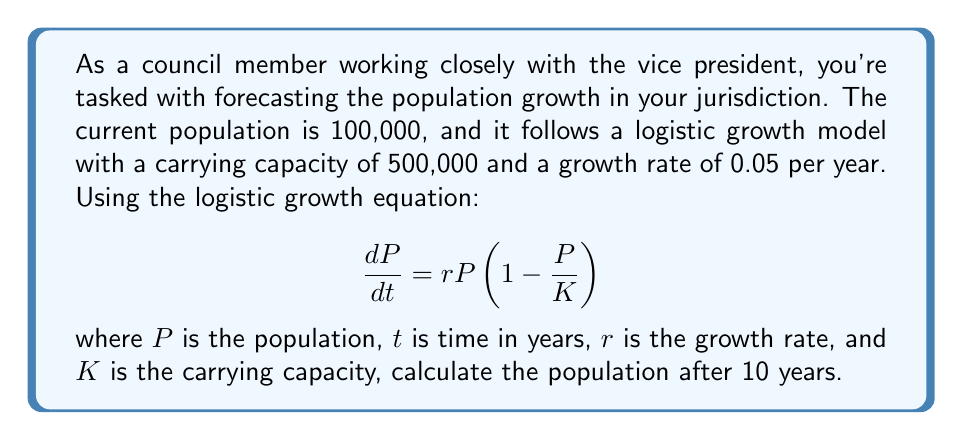Help me with this question. To solve this problem, we'll use the logistic growth model solution:

$$P(t) = \frac{K}{1 + (\frac{K}{P_0} - 1)e^{-rt}}$$

Where:
$K = 500,000$ (carrying capacity)
$P_0 = 100,000$ (initial population)
$r = 0.05$ (growth rate)
$t = 10$ (time in years)

Let's substitute these values into the equation:

$$P(10) = \frac{500,000}{1 + (\frac{500,000}{100,000} - 1)e^{-0.05 \cdot 10}}$$

$$= \frac{500,000}{1 + (5 - 1)e^{-0.5}}$$

$$= \frac{500,000}{1 + 4e^{-0.5}}$$

Now, let's calculate:

1. $e^{-0.5} \approx 0.6065$
2. $4 \cdot 0.6065 = 2.426$
3. $1 + 2.426 = 3.426$
4. $500,000 \div 3.426 \approx 145,942$

Therefore, the population after 10 years will be approximately 145,942 people.
Answer: 145,942 people 